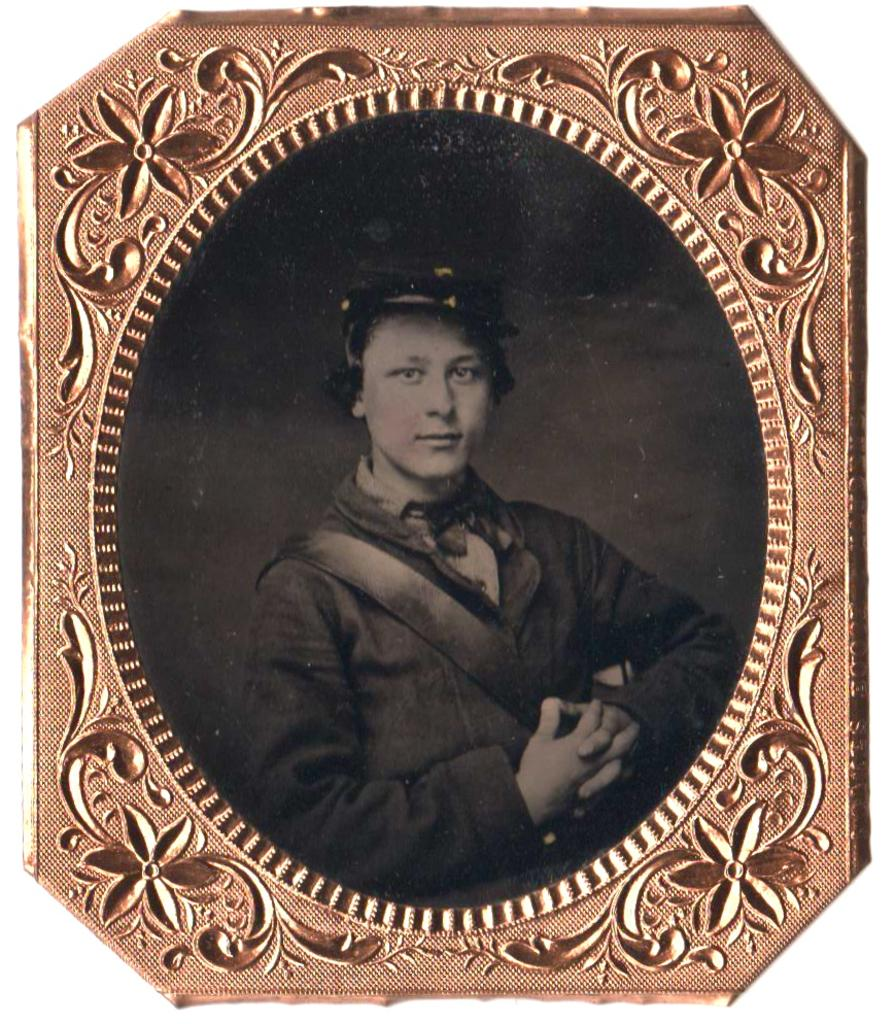What object is present in the image that typically holds a photograph or artwork? There is a picture frame in the image. What can be seen inside the picture frame? The picture frame contains an image of a person. What is the person in the image wearing on their head? The person in the image is wearing a cap. How many seats are visible in the image? There are no seats visible in the image; it only contains a picture frame with an image of a person wearing a cap. 